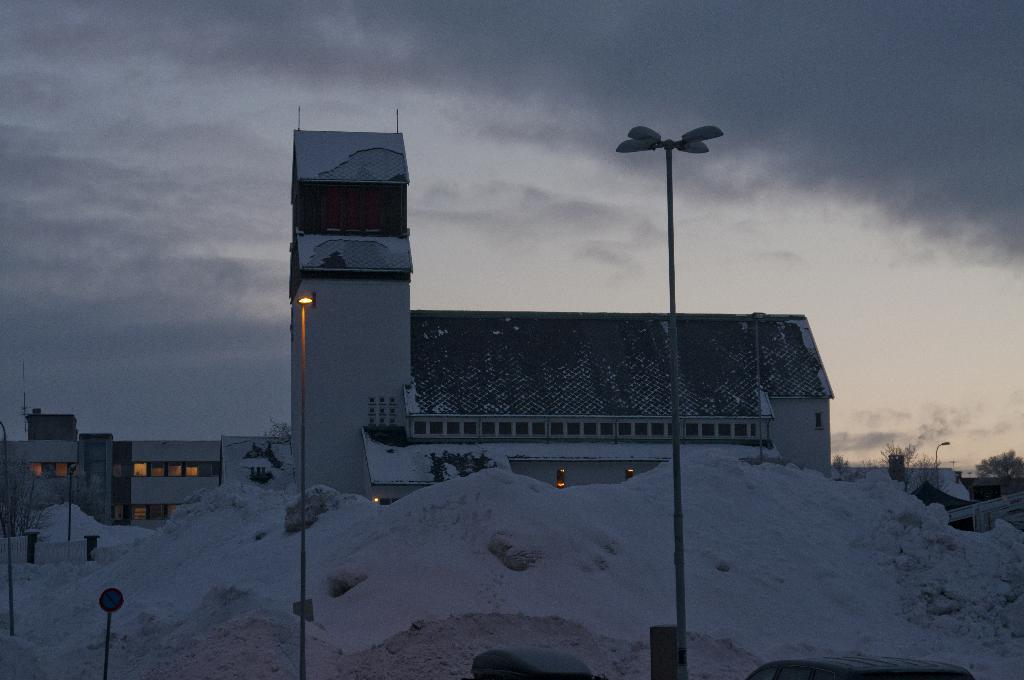What type of structures are present in the image? There are light poles, a pole with a sign board, trees, buildings, and light poles with lights in the image. What is the condition of the ground in the image? Snow is present on the ground in the image. What can be seen in the background of the image? The sky is visible in the background of the image. What type of harmony can be heard in the image? There is no audible sound in the image, so it is not possible to determine if any harmony can be heard. What type of fiction is being read by the trees in the image? There are no trees reading fiction in the image; trees are not capable of reading. 